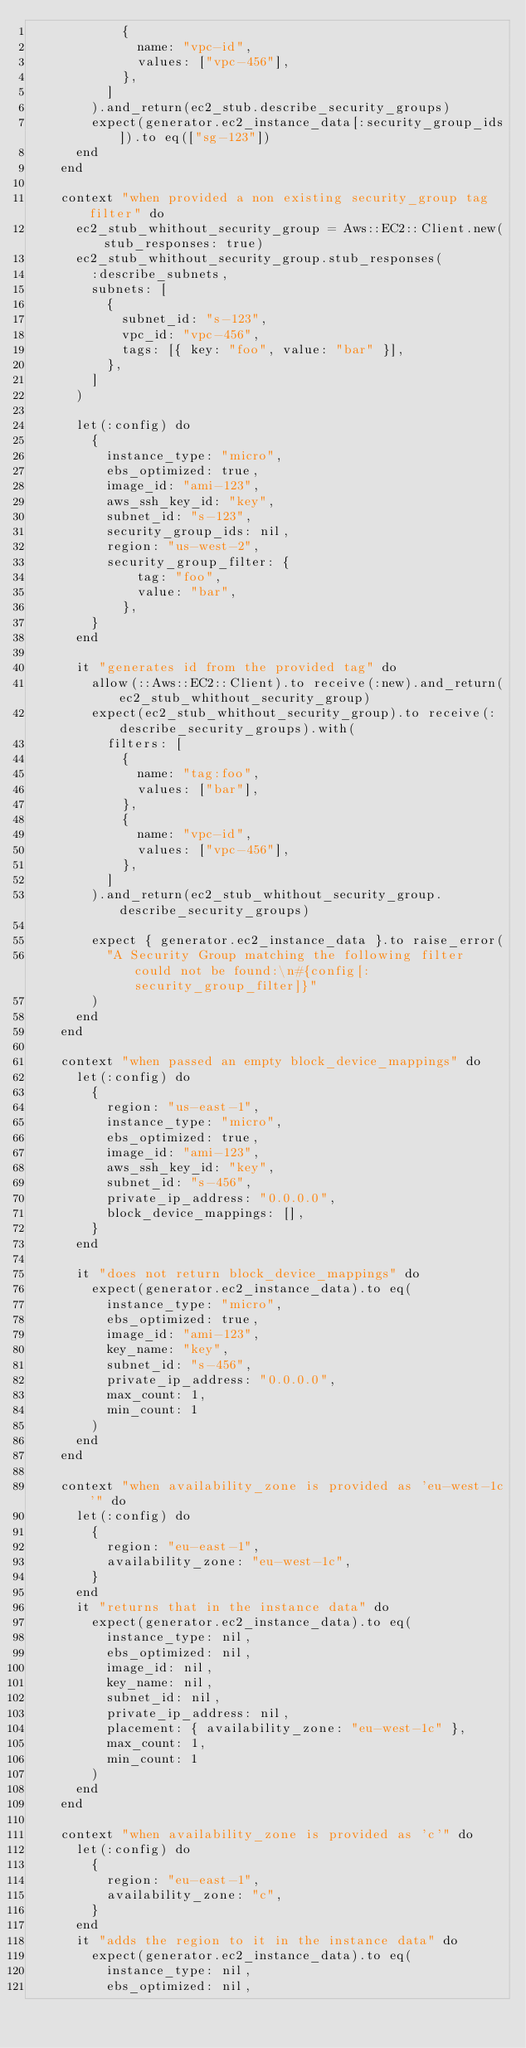<code> <loc_0><loc_0><loc_500><loc_500><_Ruby_>            {
              name: "vpc-id",
              values: ["vpc-456"],
            },
          ]
        ).and_return(ec2_stub.describe_security_groups)
        expect(generator.ec2_instance_data[:security_group_ids]).to eq(["sg-123"])
      end
    end

    context "when provided a non existing security_group tag filter" do
      ec2_stub_whithout_security_group = Aws::EC2::Client.new(stub_responses: true)
      ec2_stub_whithout_security_group.stub_responses(
        :describe_subnets,
        subnets: [
          {
            subnet_id: "s-123",
            vpc_id: "vpc-456",
            tags: [{ key: "foo", value: "bar" }],
          },
        ]
      )

      let(:config) do
        {
          instance_type: "micro",
          ebs_optimized: true,
          image_id: "ami-123",
          aws_ssh_key_id: "key",
          subnet_id: "s-123",
          security_group_ids: nil,
          region: "us-west-2",
          security_group_filter: {
              tag: "foo",
              value: "bar",
            },
        }
      end

      it "generates id from the provided tag" do
        allow(::Aws::EC2::Client).to receive(:new).and_return(ec2_stub_whithout_security_group)
        expect(ec2_stub_whithout_security_group).to receive(:describe_security_groups).with(
          filters: [
            {
              name: "tag:foo",
              values: ["bar"],
            },
            {
              name: "vpc-id",
              values: ["vpc-456"],
            },
          ]
        ).and_return(ec2_stub_whithout_security_group.describe_security_groups)

        expect { generator.ec2_instance_data }.to raise_error(
          "A Security Group matching the following filter could not be found:\n#{config[:security_group_filter]}"
        )
      end
    end

    context "when passed an empty block_device_mappings" do
      let(:config) do
        {
          region: "us-east-1",
          instance_type: "micro",
          ebs_optimized: true,
          image_id: "ami-123",
          aws_ssh_key_id: "key",
          subnet_id: "s-456",
          private_ip_address: "0.0.0.0",
          block_device_mappings: [],
        }
      end

      it "does not return block_device_mappings" do
        expect(generator.ec2_instance_data).to eq(
          instance_type: "micro",
          ebs_optimized: true,
          image_id: "ami-123",
          key_name: "key",
          subnet_id: "s-456",
          private_ip_address: "0.0.0.0",
          max_count: 1,
          min_count: 1
        )
      end
    end

    context "when availability_zone is provided as 'eu-west-1c'" do
      let(:config) do
        {
          region: "eu-east-1",
          availability_zone: "eu-west-1c",
        }
      end
      it "returns that in the instance data" do
        expect(generator.ec2_instance_data).to eq(
          instance_type: nil,
          ebs_optimized: nil,
          image_id: nil,
          key_name: nil,
          subnet_id: nil,
          private_ip_address: nil,
          placement: { availability_zone: "eu-west-1c" },
          max_count: 1,
          min_count: 1
        )
      end
    end

    context "when availability_zone is provided as 'c'" do
      let(:config) do
        {
          region: "eu-east-1",
          availability_zone: "c",
        }
      end
      it "adds the region to it in the instance data" do
        expect(generator.ec2_instance_data).to eq(
          instance_type: nil,
          ebs_optimized: nil,</code> 